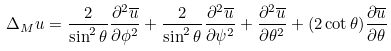<formula> <loc_0><loc_0><loc_500><loc_500>\Delta _ { M } u = \frac { 2 } { \sin ^ { 2 } \theta } \frac { \partial ^ { 2 } \overline { u } } { \partial \phi ^ { 2 } } + \frac { 2 } { \sin ^ { 2 } \theta } \frac { \partial ^ { 2 } \overline { u } } { \partial \psi ^ { 2 } } + \frac { \partial ^ { 2 } \overline { u } } { \partial \theta ^ { 2 } } + ( 2 \cot \theta ) \frac { \partial \overline { u } } { \partial \theta }</formula> 